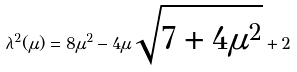Convert formula to latex. <formula><loc_0><loc_0><loc_500><loc_500>\lambda ^ { 2 } ( \mu ) = 8 \mu ^ { 2 } - 4 \mu \sqrt { 7 + 4 \mu ^ { 2 } } + 2</formula> 